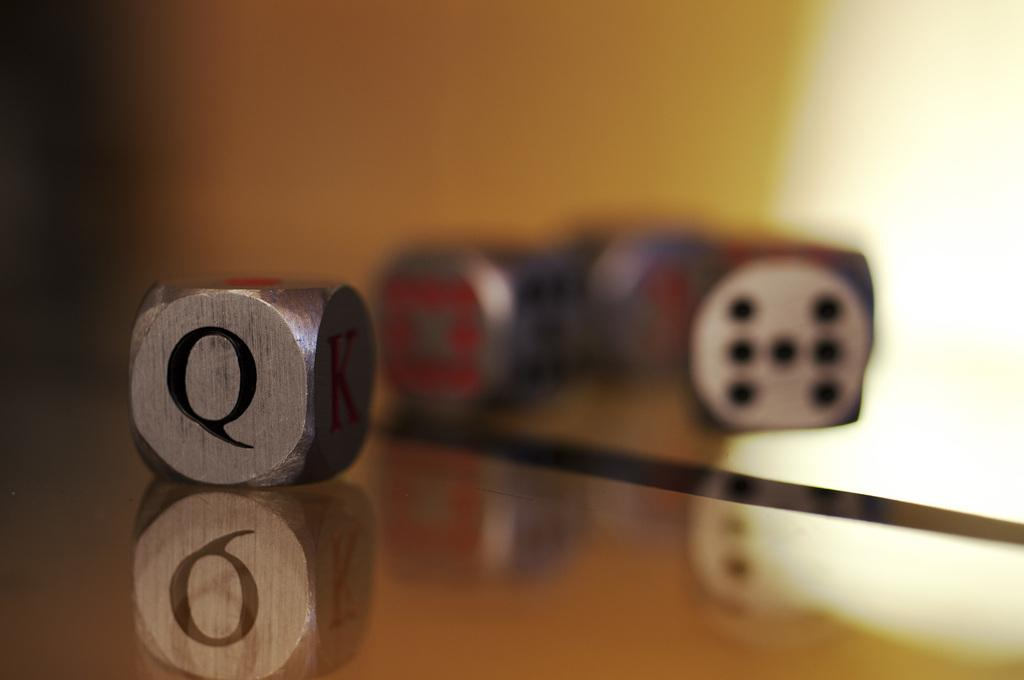What objects are on the surface in the image? There are dice on a surface in the image. Can you describe any additional features related to the dice? Yes, there is a reflection of the dice on the surface. What type of drum can be seen in the reflection of the dice? There is no drum present in the image, and therefore no such object can be seen in the reflection of the dice. 